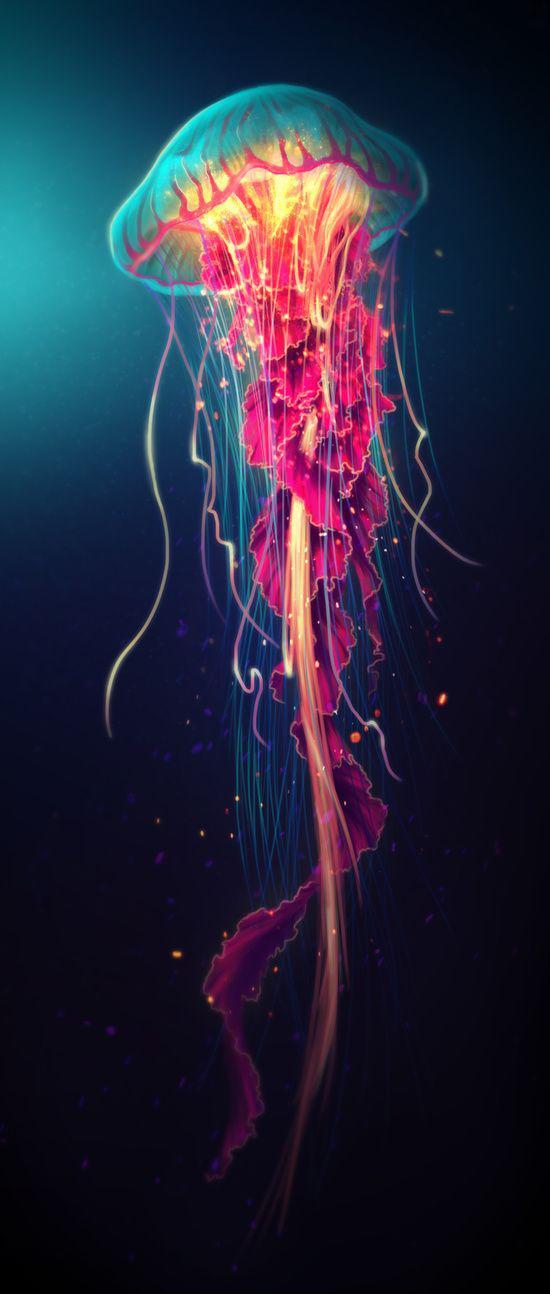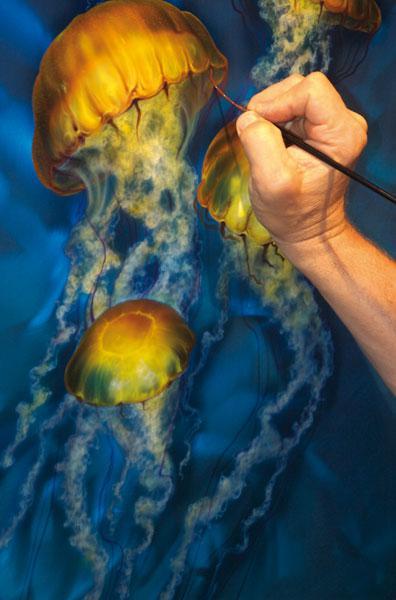The first image is the image on the left, the second image is the image on the right. Considering the images on both sides, is "An image shows a hand at the right painting a jellyfish scene." valid? Answer yes or no. Yes. The first image is the image on the left, the second image is the image on the right. Assess this claim about the two images: "A person is painting a picture of jellyfish in one of the images.". Correct or not? Answer yes or no. Yes. 